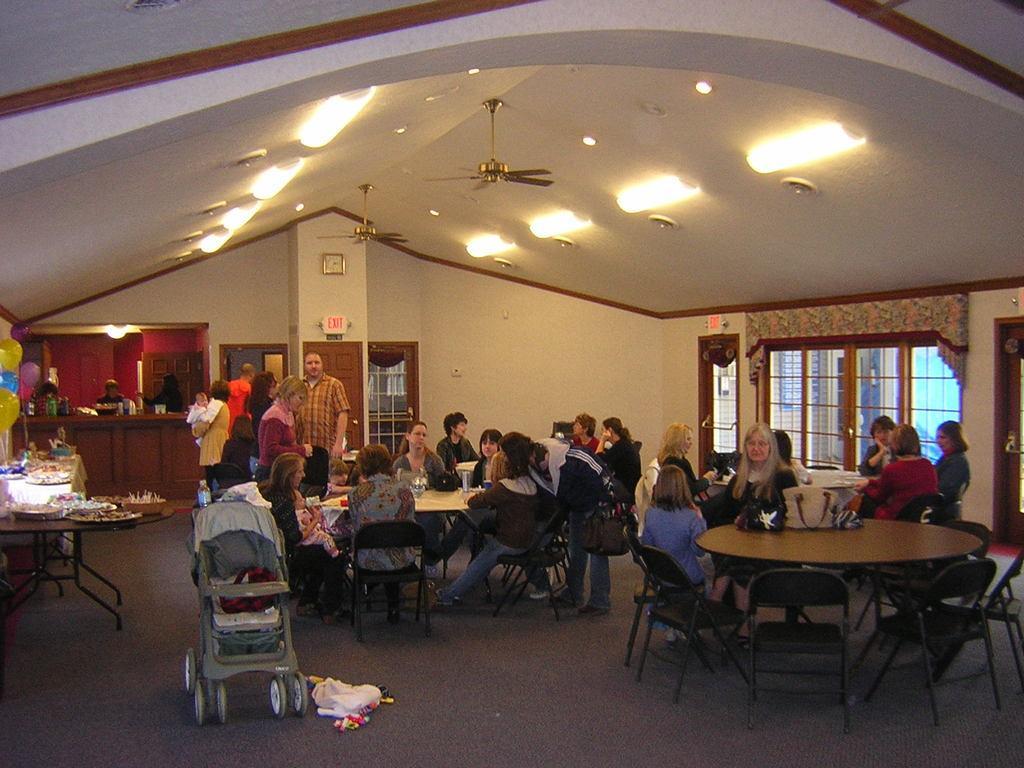Describe this image in one or two sentences. people are seated on the chairs, around the tables. a baby cot is present in the front. balloons are present at the left corner and on the top there are fans and lights. 